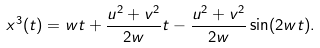Convert formula to latex. <formula><loc_0><loc_0><loc_500><loc_500>x ^ { 3 } ( t ) = w t + \frac { u ^ { 2 } + v ^ { 2 } } { 2 w } t - \frac { u ^ { 2 } + v ^ { 2 } } { 2 w } \sin ( 2 w t ) .</formula> 